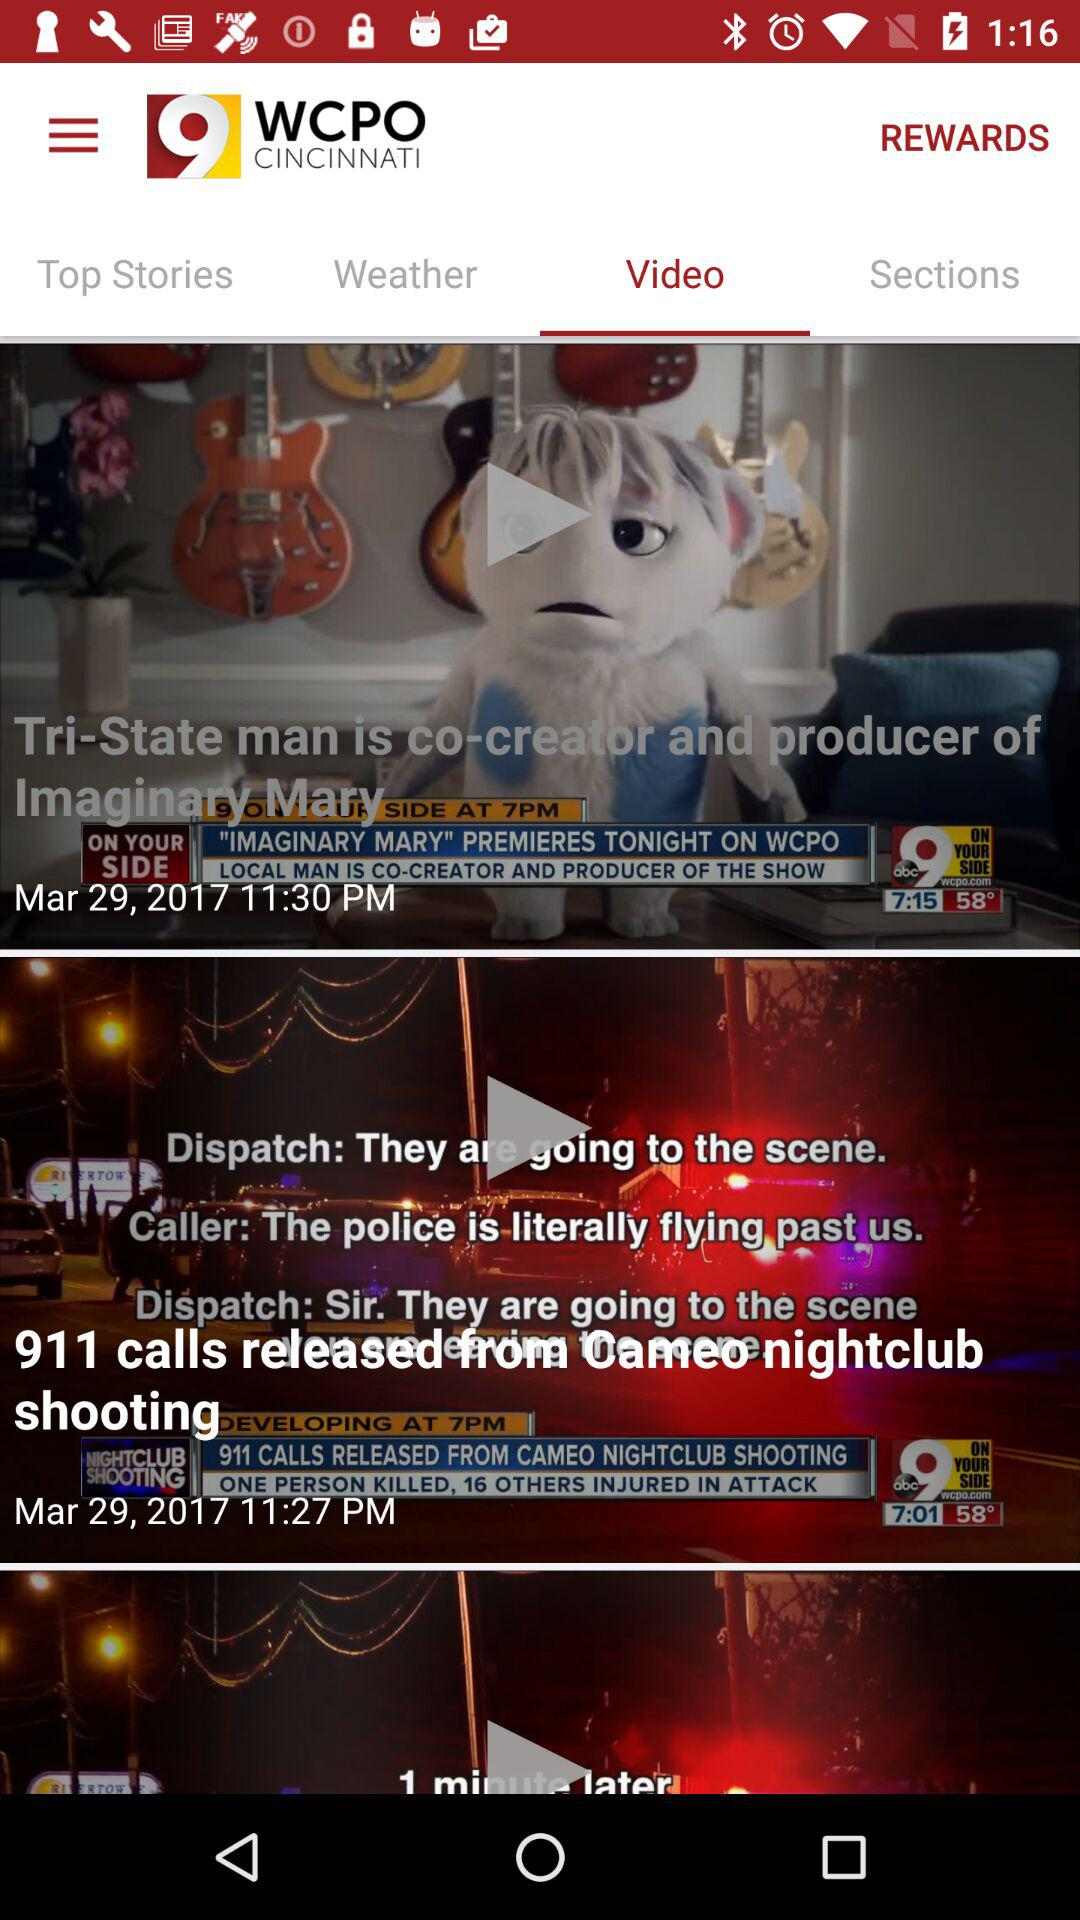How many calls have been released from the "Cameo nightclub" shooting? There are 911 calls released from the "Cameo nightclub" shooting. 